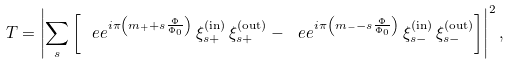<formula> <loc_0><loc_0><loc_500><loc_500>T = \left | \sum _ { s } \left [ \ e e ^ { i \pi \left ( m _ { + } + s \frac { \Phi } { \Phi _ { 0 } } \right ) } \, \xi _ { s + } ^ { \text {(in)} } \, \xi _ { s + } ^ { \text {(out)} } - \ e e ^ { i \pi \left ( m _ { - } - s \frac { \Phi } { \Phi _ { 0 } } \right ) } \, \xi _ { s - } ^ { \text {(in)} } \, \xi _ { s - } ^ { \text {(out)} } \right ] \right | ^ { 2 } ,</formula> 